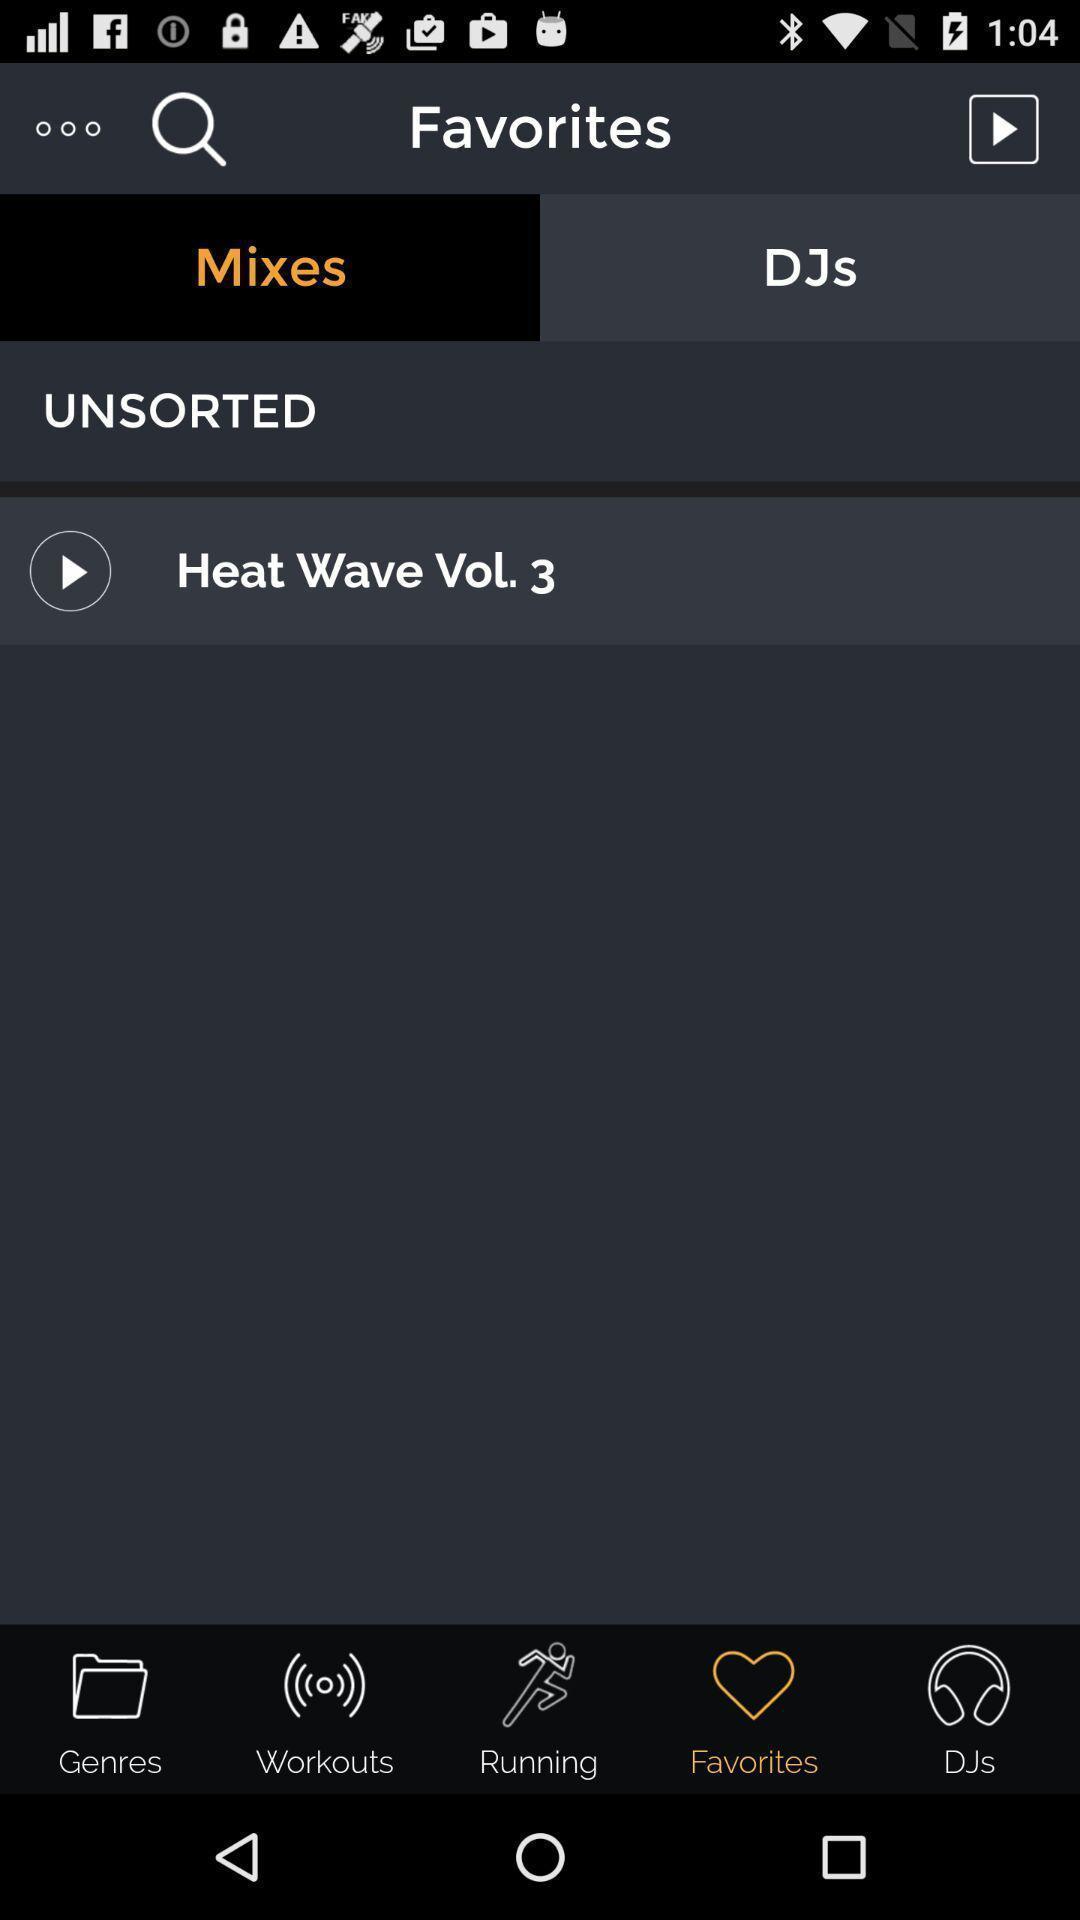Give me a narrative description of this picture. Screen showing mixes of favorites on a device. 